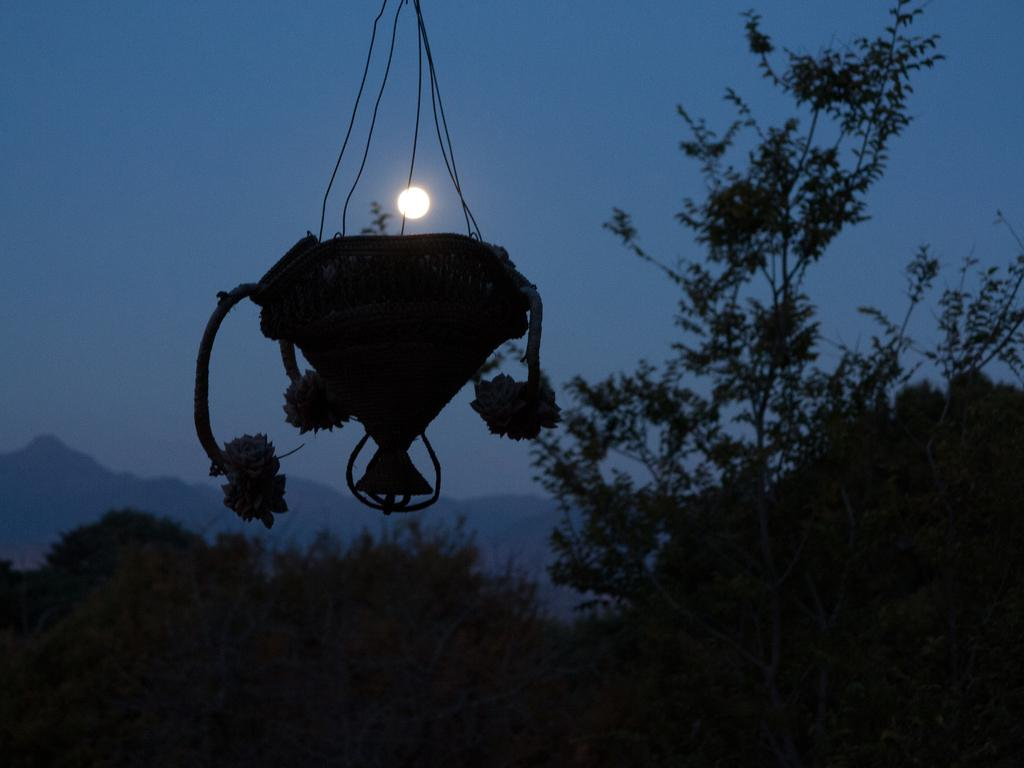What is hanging in the image? There is a hanging flower pot in the image. What type of vegetation can be seen at the bottom of the image? Trees are visible at the bottom of the image. What geographical features are present in the background of the image? There are mountains in the background of the image. What part of the natural environment is visible in the background of the image? The sky is visible in the background of the image. What does the girl's dad say about the existence of the mountains in the image? There is no girl or dad present in the image, so it is not possible to answer that question. 